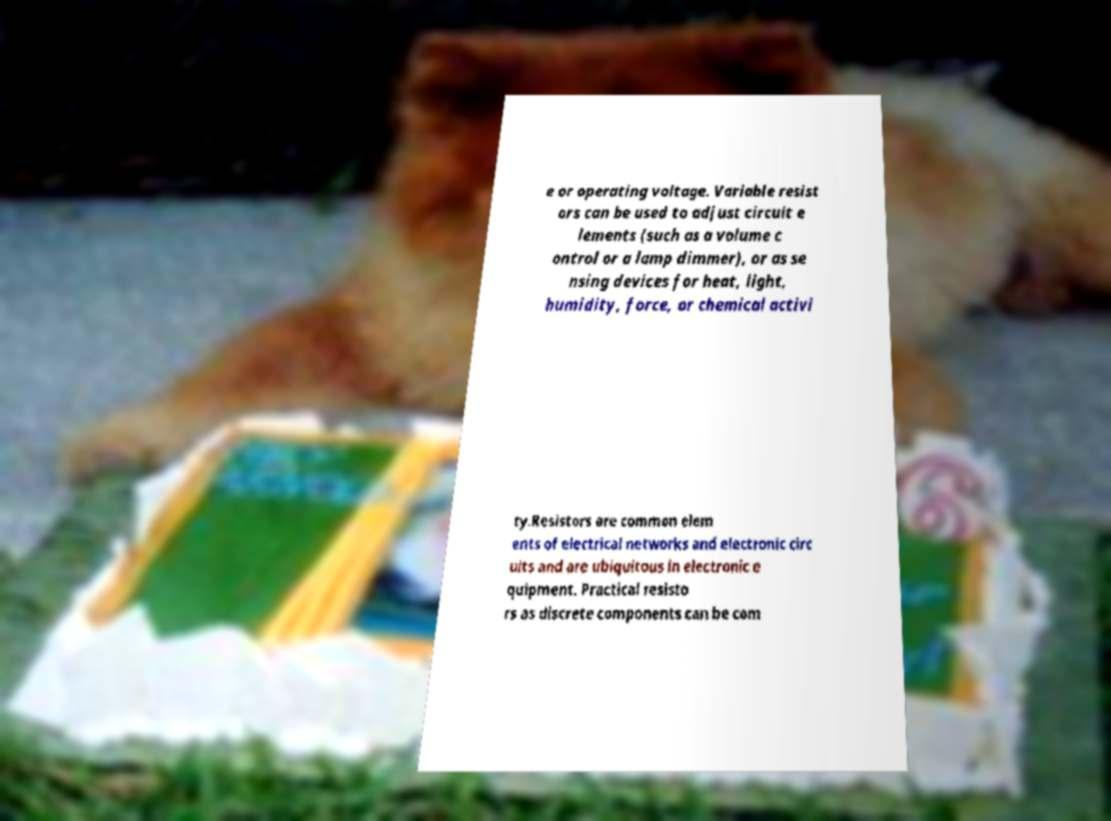I need the written content from this picture converted into text. Can you do that? e or operating voltage. Variable resist ors can be used to adjust circuit e lements (such as a volume c ontrol or a lamp dimmer), or as se nsing devices for heat, light, humidity, force, or chemical activi ty.Resistors are common elem ents of electrical networks and electronic circ uits and are ubiquitous in electronic e quipment. Practical resisto rs as discrete components can be com 